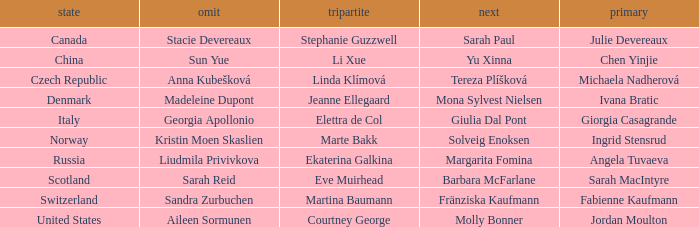What skip has martina baumann as the third? Sandra Zurbuchen. 